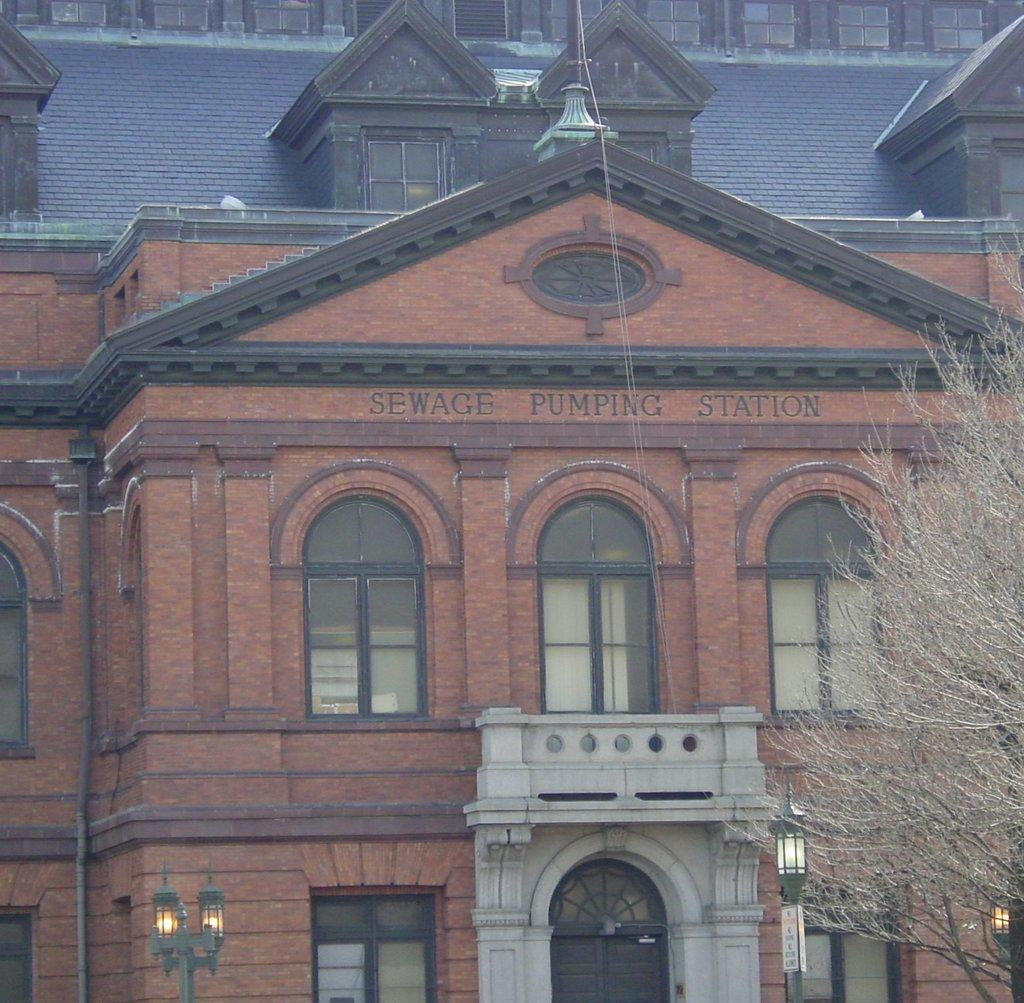What type of structures can be seen in the image? There are street lights and a building with windows and a door in the image. Where are the trees located in the image? The trees are on the right side of the image. How many visitors can be seen with tails in the image? There are no visitors or tails present in the image. What type of learning can be observed taking place in the image? There is no learning activity depicted in the image. 